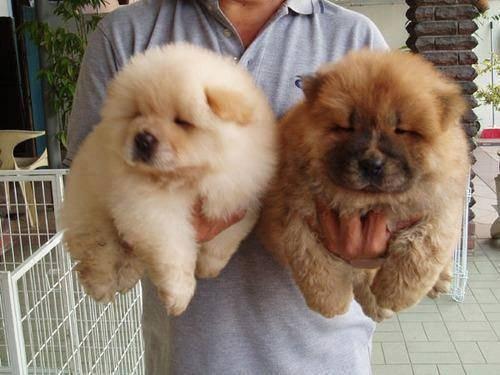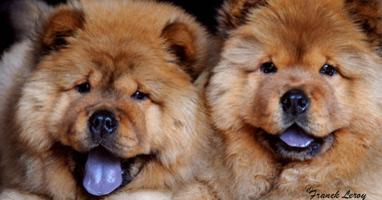The first image is the image on the left, the second image is the image on the right. Analyze the images presented: Is the assertion "There are 4 chows in the image pair" valid? Answer yes or no. Yes. The first image is the image on the left, the second image is the image on the right. Assess this claim about the two images: "The right image contains exactly two chow dogs.". Correct or not? Answer yes or no. Yes. 